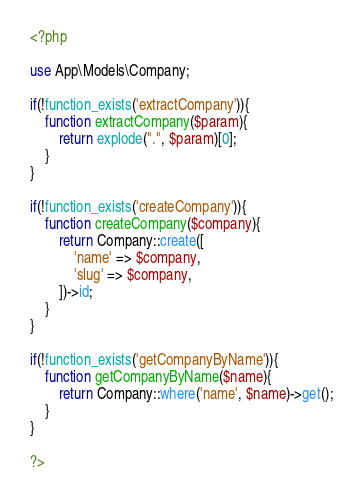<code> <loc_0><loc_0><loc_500><loc_500><_PHP_><?php

use App\Models\Company;

if(!function_exists('extractCompany')){
    function extractCompany($param){
        return explode(".", $param)[0];
    }
}

if(!function_exists('createCompany')){
    function createCompany($company){        
        return Company::create([
            'name' => $company,
            'slug' => $company,
        ])->id;
    }
}

if(!function_exists('getCompanyByName')){
    function getCompanyByName($name){
        return Company::where('name', $name)->get();
    }
}

?></code> 